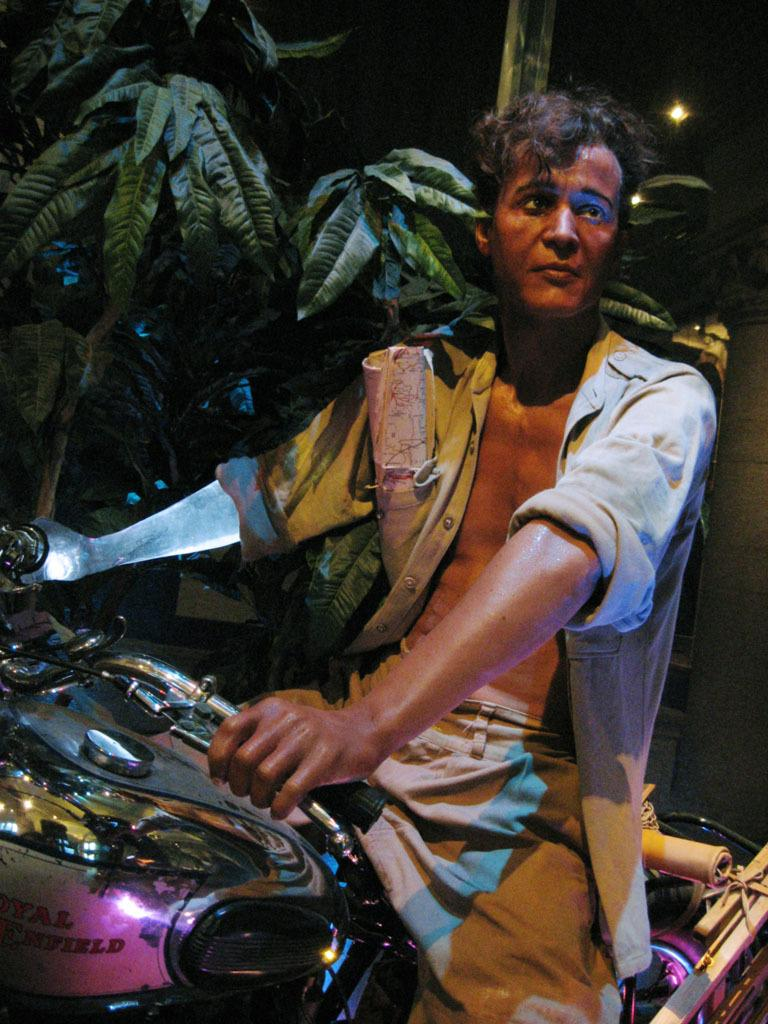Who is present in the image? There is a man in the image. What is the man doing in the image? The man is sitting on a motorbike. What can be seen beside the motorbike? There is a tree beside the motorbike. What is the source of light in the image? There is a light visible in the image. Where is the bucket located in the image? There is no bucket present in the image. What type of garden can be seen in the image? There is no garden present in the image. 